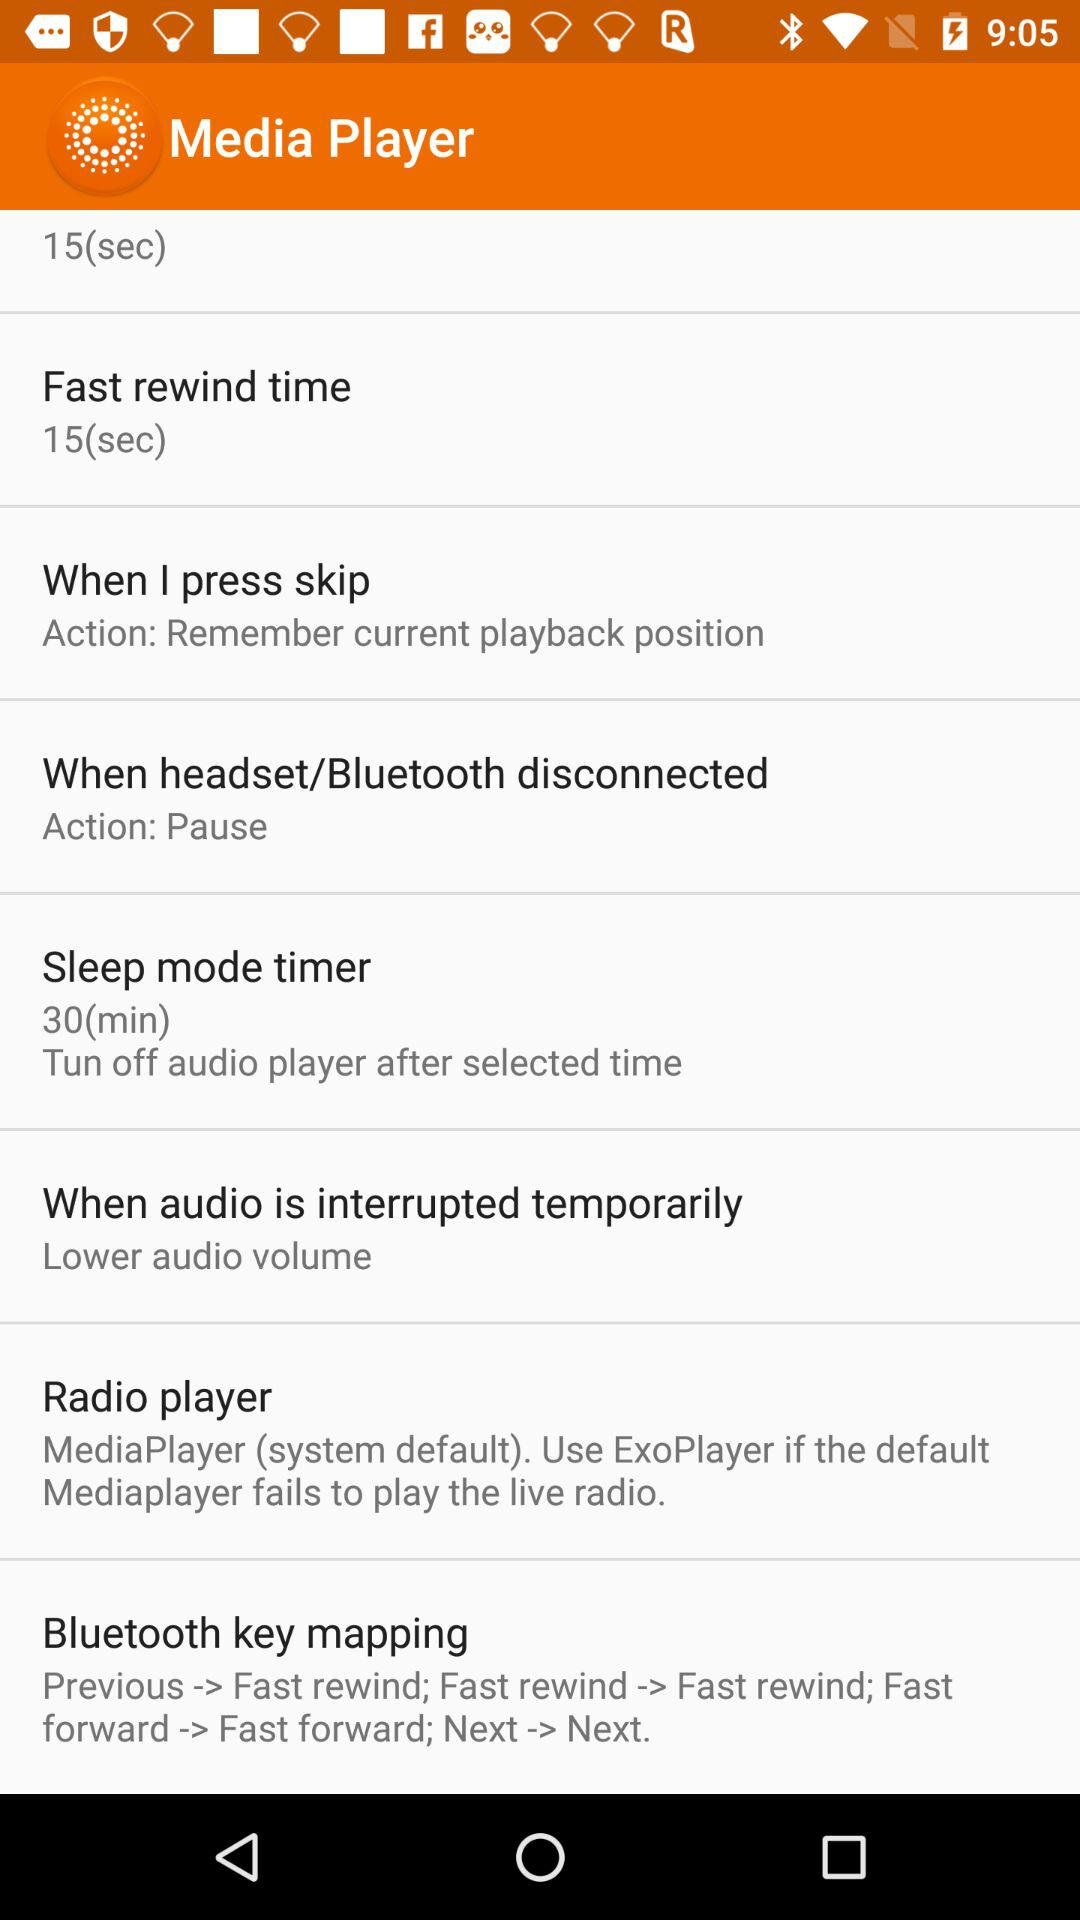What situation is for "Action: Pause"? The situation is "When headset/Bluetooth disconnected". 